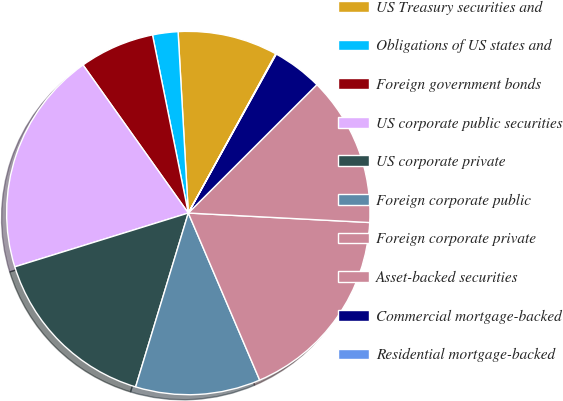Convert chart to OTSL. <chart><loc_0><loc_0><loc_500><loc_500><pie_chart><fcel>US Treasury securities and<fcel>Obligations of US states and<fcel>Foreign government bonds<fcel>US corporate public securities<fcel>US corporate private<fcel>Foreign corporate public<fcel>Foreign corporate private<fcel>Asset-backed securities<fcel>Commercial mortgage-backed<fcel>Residential mortgage-backed<nl><fcel>8.89%<fcel>2.26%<fcel>6.68%<fcel>19.95%<fcel>15.53%<fcel>11.11%<fcel>17.74%<fcel>13.32%<fcel>4.47%<fcel>0.05%<nl></chart> 